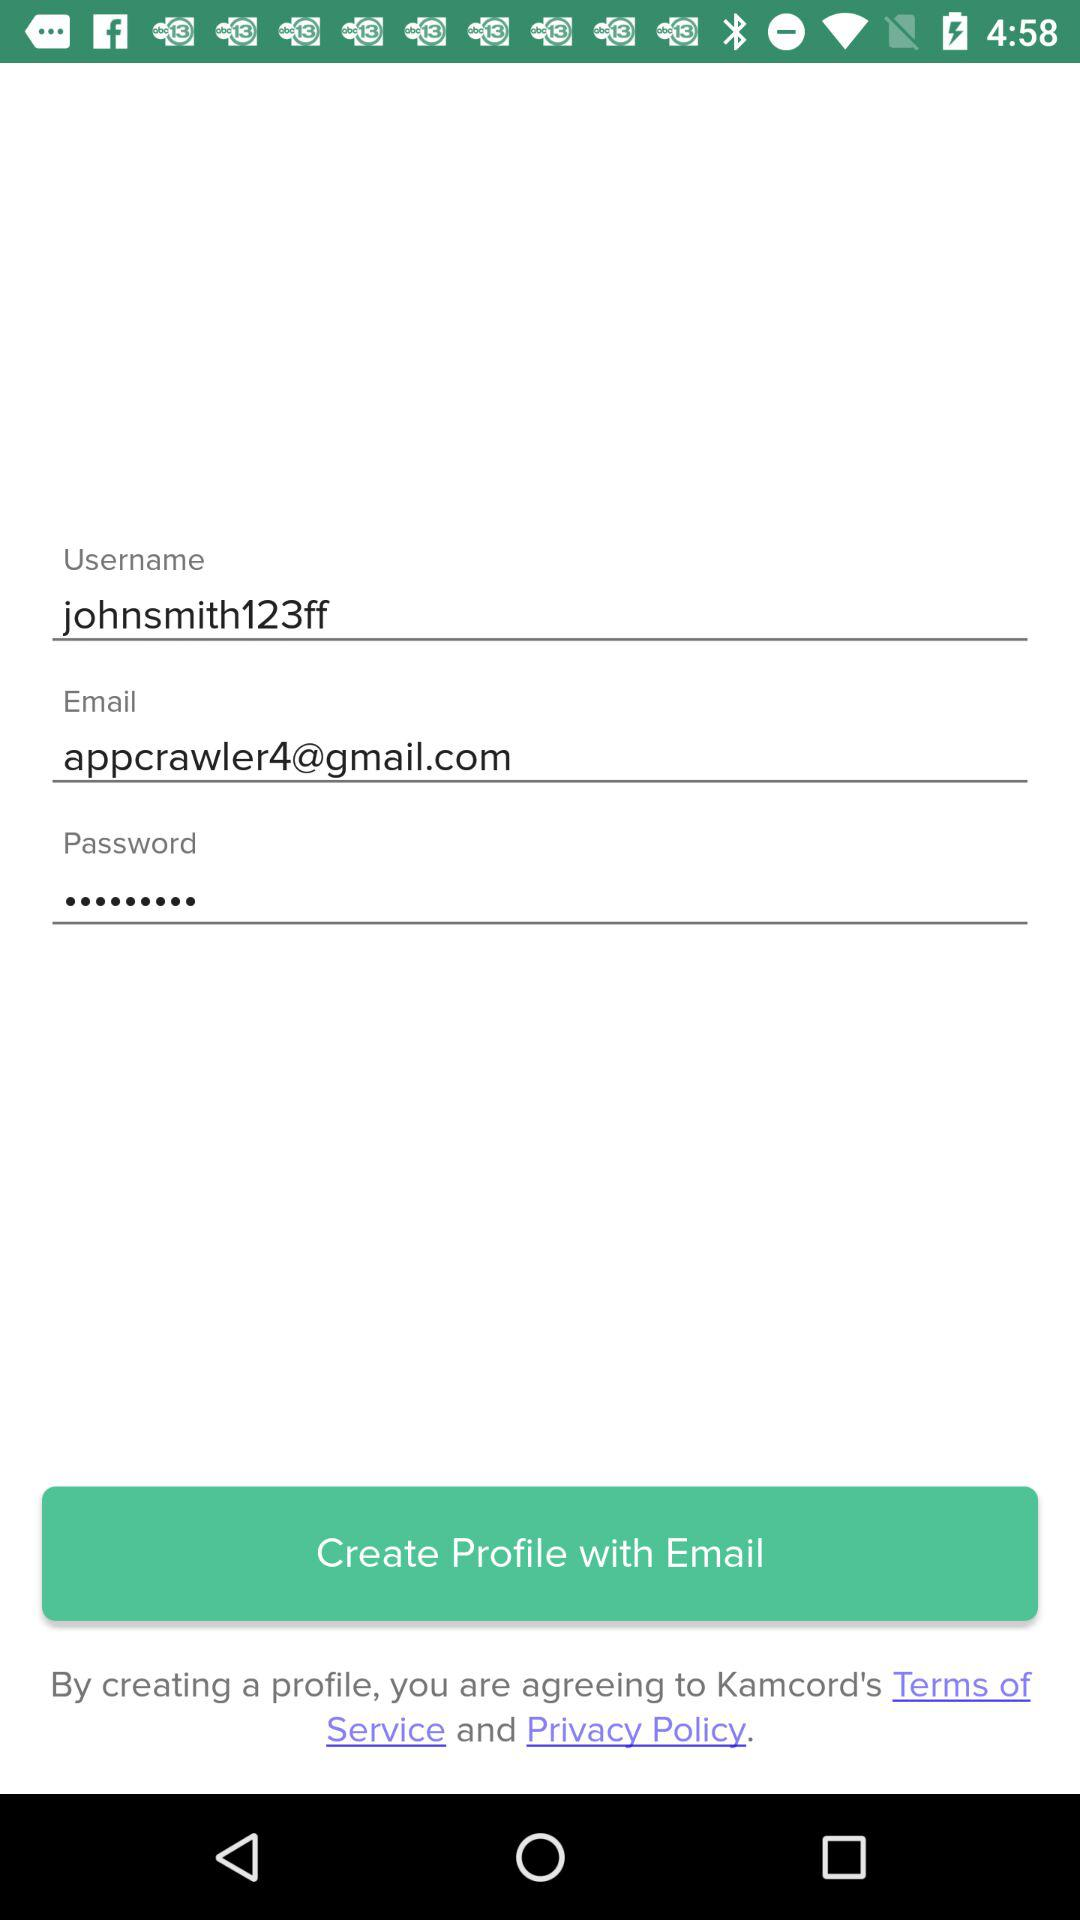What is the username? The username is johnsmith123ff. 